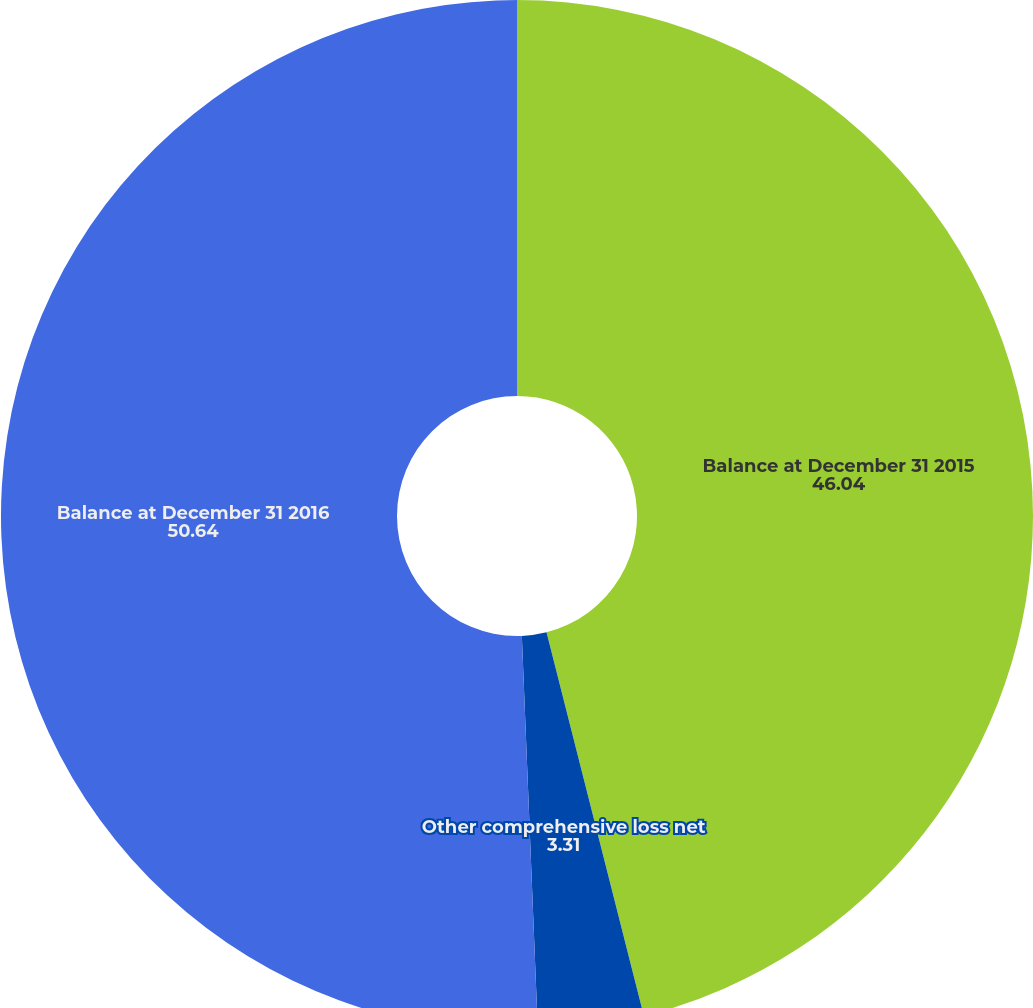Convert chart to OTSL. <chart><loc_0><loc_0><loc_500><loc_500><pie_chart><fcel>Balance at December 31 2015<fcel>Other comprehensive loss net<fcel>Balance at December 31 2016<nl><fcel>46.04%<fcel>3.31%<fcel>50.64%<nl></chart> 